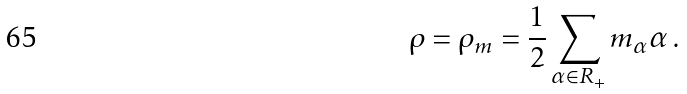<formula> <loc_0><loc_0><loc_500><loc_500>\rho = \rho _ { m } = \frac { 1 } { 2 } \sum _ { \alpha \in R _ { + } } m _ { \alpha } \alpha \, .</formula> 